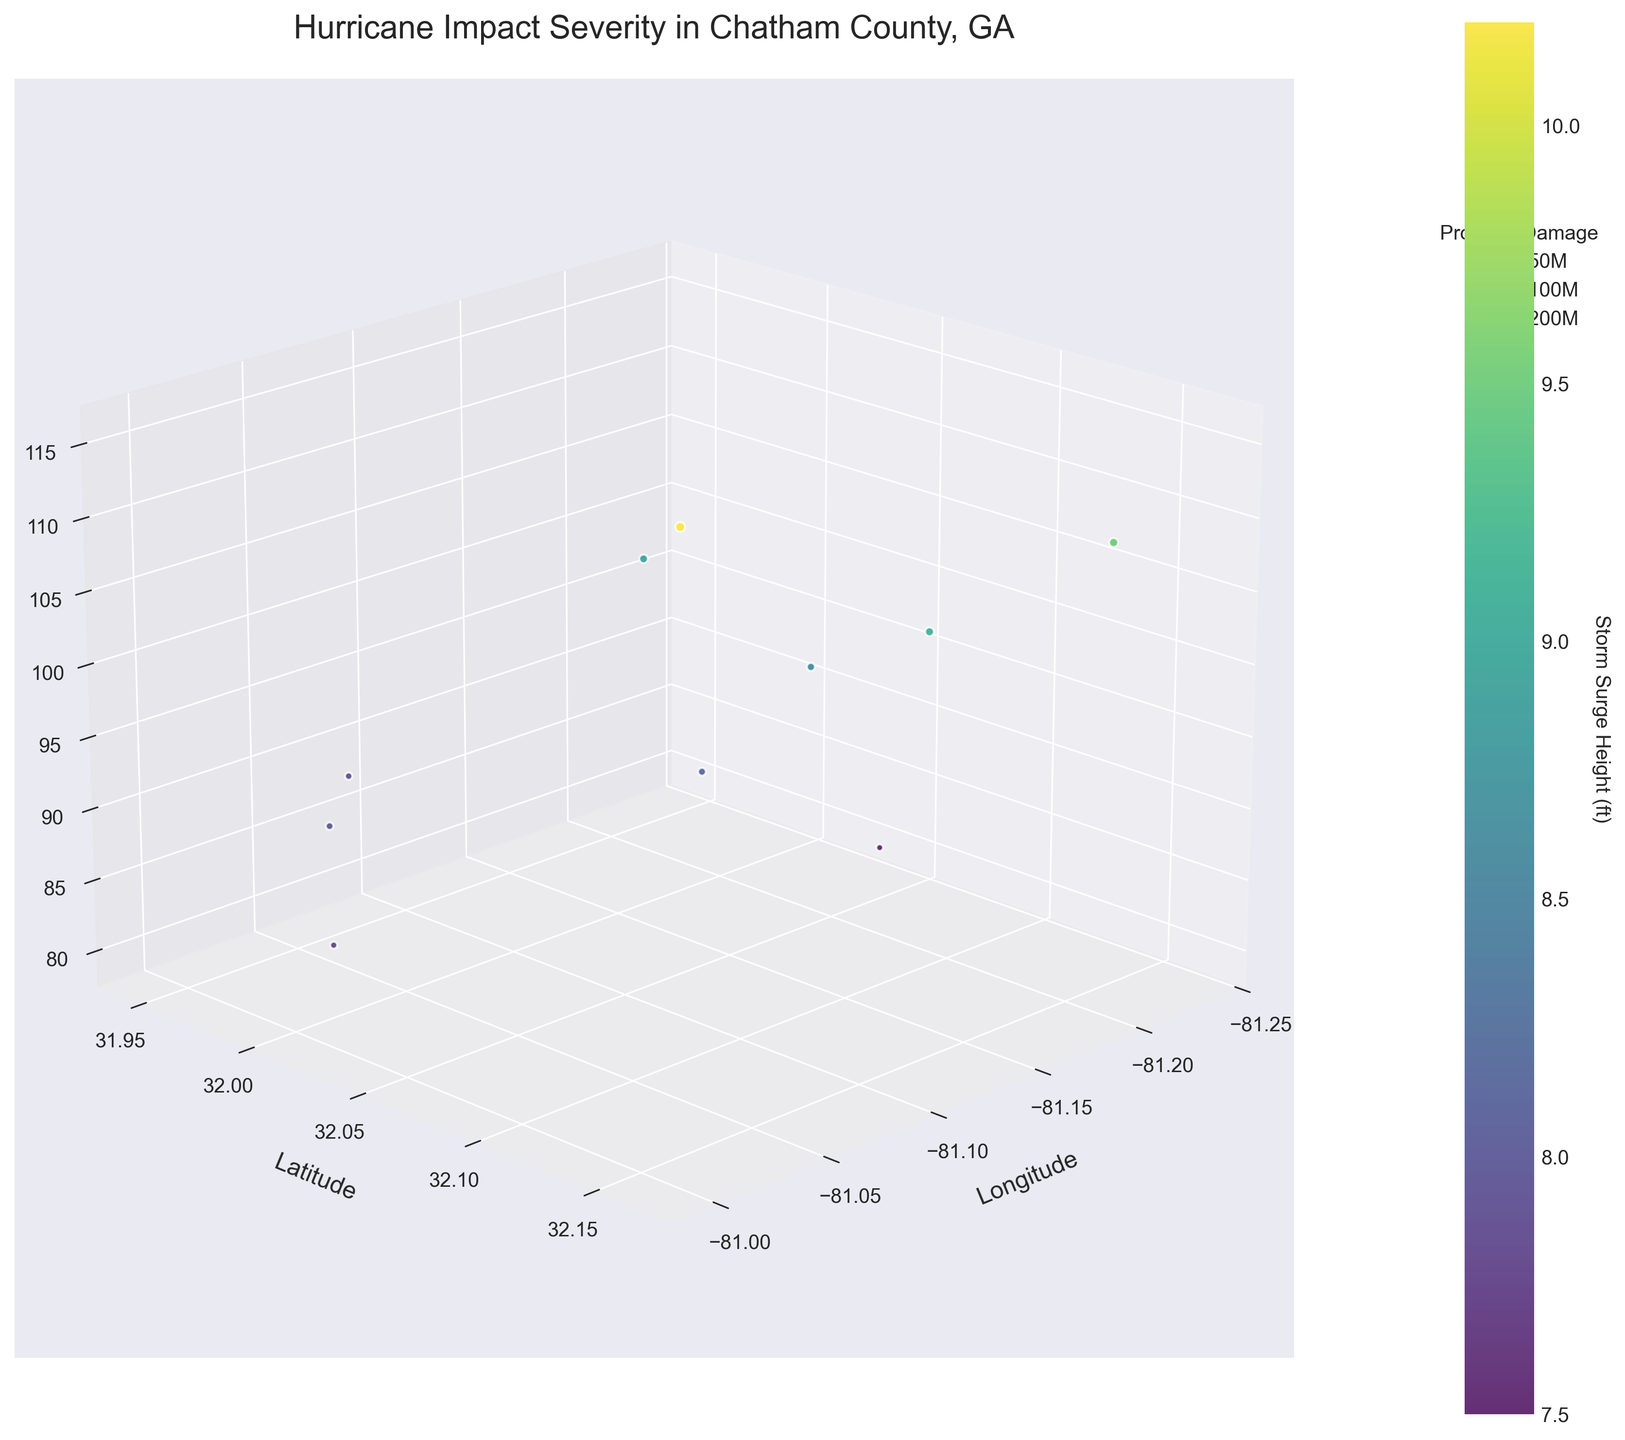What does the color hue represent on the plot? The colors represent the storm surge height, with different hues indicating varying heights. The color bar on the right provides a scale from the lowest to the highest storm surge heights in feet.
Answer: Storm surge height How many data points are plotted in the figure? By counting each dot in the plot, you will see that there are 10 points representing the different data entries.
Answer: 10 Which location experienced the highest wind speed? Look for the highest point along the Wind Speed (z-axis). The coordinate at Latitude 32.1128 and Longitude -81.0578 has the highest wind speed of 115 mph.
Answer: Latitude 32.1128 and Longitude -81.0578 Which data point has the smallest property damage estimate? The sizes of the dots correlate to property damage estimates. The smallest dot has an estimate of $110 million, found at coordinates Latitude 32.0405 and Longitude -81.2351.
Answer: Latitude 32.0405 and Longitude -81.2351 Which property experienced the highest property damage and what are its wind speed and storm surge height? The largest dot indicates the highest property damage estimate of $230 million, with a corresponding wind speed of 115 mph and a storm surge height of 10.2 ft at coordinates Latitude 32.1128 and Longitude -81.0578.
Answer: Damage: $230 million, Wind Speed: 115 mph, Storm Surge: 10.2 ft On average, what is the wind speed across all data points? Sum up all the wind speeds: 95+110+85+100+105+90+80+115+98+88 = 966. Then, divide by the number of points: 966/10 = 96.6 mph.
Answer: 96.6 mph Which pair of locations has the greatest difference in storm surge height? Identify the points with the maximum and minimum storm surge heights. The highest is 10.2 ft and the lowest is 7.5 ft. The difference is 10.2 - 7.5 = 2.7 ft. These correspond to points at Latitude 32.1128 and Longitude -81.0578, and Latitude 32.0405 and Longitude -81.2351.
Answer: Difference: 2.7 ft (Latitude 32.1128 and Longitude -81.0578 vs. Latitude 32.0405 and Longitude -81.2351) What is the average property damage estimate? Sum all property damage estimates: 150M + 200M + 120M + 180M + 190M + 140M + 110M + 230M + 160M + 130M = 1610M. Then, divide by the number of points: 1610M/10 = 161M dollars.
Answer: $161 million What longitude value corresponds to the highest storm surge height? Locate the highest color hue in the color bar, which corresponds to the maximum storm surge height of 10.2 ft. This is at Longitude -81.0578.
Answer: Longitude -81.0578 